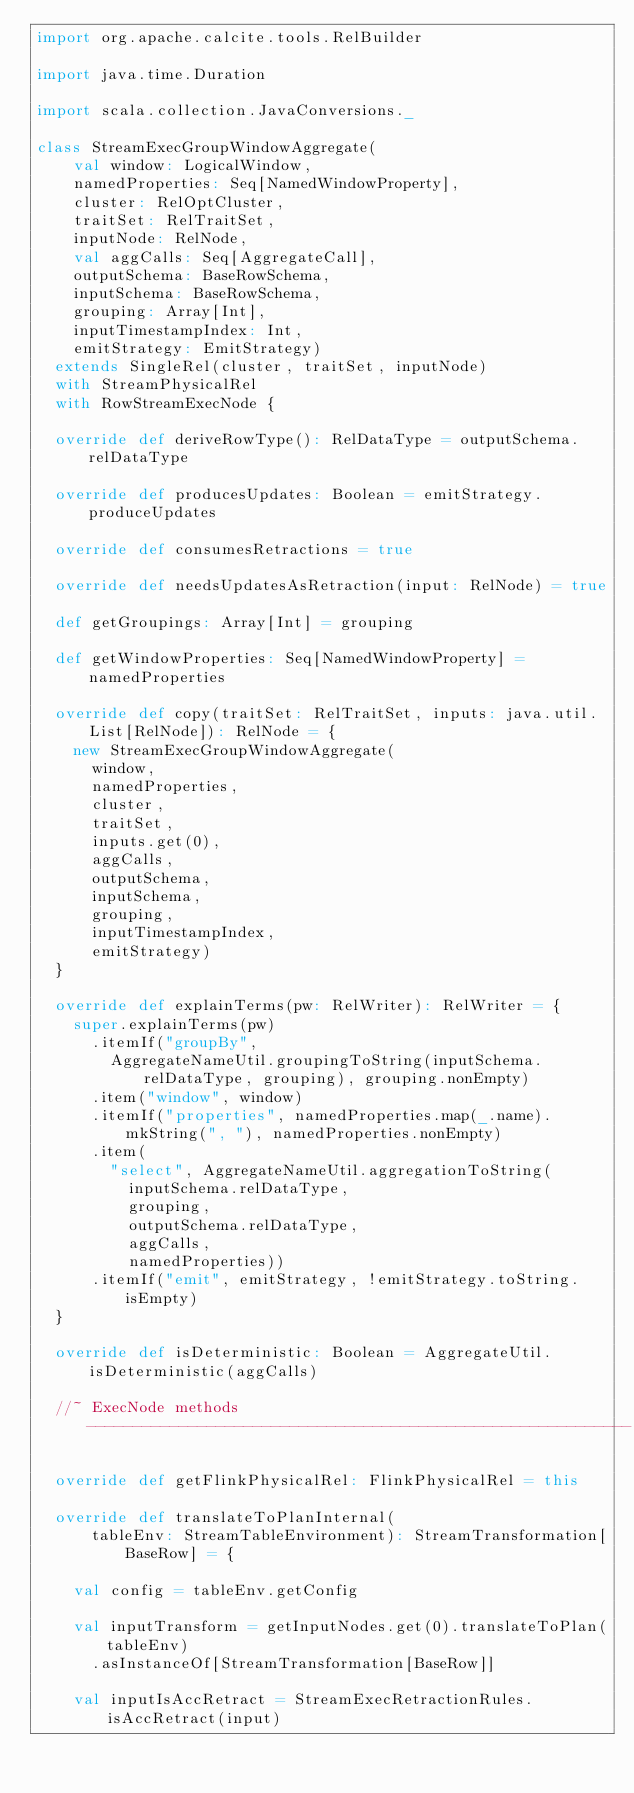<code> <loc_0><loc_0><loc_500><loc_500><_Scala_>import org.apache.calcite.tools.RelBuilder

import java.time.Duration

import scala.collection.JavaConversions._

class StreamExecGroupWindowAggregate(
    val window: LogicalWindow,
    namedProperties: Seq[NamedWindowProperty],
    cluster: RelOptCluster,
    traitSet: RelTraitSet,
    inputNode: RelNode,
    val aggCalls: Seq[AggregateCall],
    outputSchema: BaseRowSchema,
    inputSchema: BaseRowSchema,
    grouping: Array[Int],
    inputTimestampIndex: Int,
    emitStrategy: EmitStrategy)
  extends SingleRel(cluster, traitSet, inputNode)
  with StreamPhysicalRel
  with RowStreamExecNode {

  override def deriveRowType(): RelDataType = outputSchema.relDataType

  override def producesUpdates: Boolean = emitStrategy.produceUpdates

  override def consumesRetractions = true

  override def needsUpdatesAsRetraction(input: RelNode) = true

  def getGroupings: Array[Int] = grouping

  def getWindowProperties: Seq[NamedWindowProperty] = namedProperties

  override def copy(traitSet: RelTraitSet, inputs: java.util.List[RelNode]): RelNode = {
    new StreamExecGroupWindowAggregate(
      window,
      namedProperties,
      cluster,
      traitSet,
      inputs.get(0),
      aggCalls,
      outputSchema,
      inputSchema,
      grouping,
      inputTimestampIndex,
      emitStrategy)
  }

  override def explainTerms(pw: RelWriter): RelWriter = {
    super.explainTerms(pw)
      .itemIf("groupBy",
        AggregateNameUtil.groupingToString(inputSchema.relDataType, grouping), grouping.nonEmpty)
      .item("window", window)
      .itemIf("properties", namedProperties.map(_.name).mkString(", "), namedProperties.nonEmpty)
      .item(
        "select", AggregateNameUtil.aggregationToString(
          inputSchema.relDataType,
          grouping,
          outputSchema.relDataType,
          aggCalls,
          namedProperties))
      .itemIf("emit", emitStrategy, !emitStrategy.toString.isEmpty)
  }

  override def isDeterministic: Boolean = AggregateUtil.isDeterministic(aggCalls)

  //~ ExecNode methods -----------------------------------------------------------

  override def getFlinkPhysicalRel: FlinkPhysicalRel = this

  override def translateToPlanInternal(
      tableEnv: StreamTableEnvironment): StreamTransformation[BaseRow] = {

    val config = tableEnv.getConfig

    val inputTransform = getInputNodes.get(0).translateToPlan(tableEnv)
      .asInstanceOf[StreamTransformation[BaseRow]]

    val inputIsAccRetract = StreamExecRetractionRules.isAccRetract(input)
</code> 